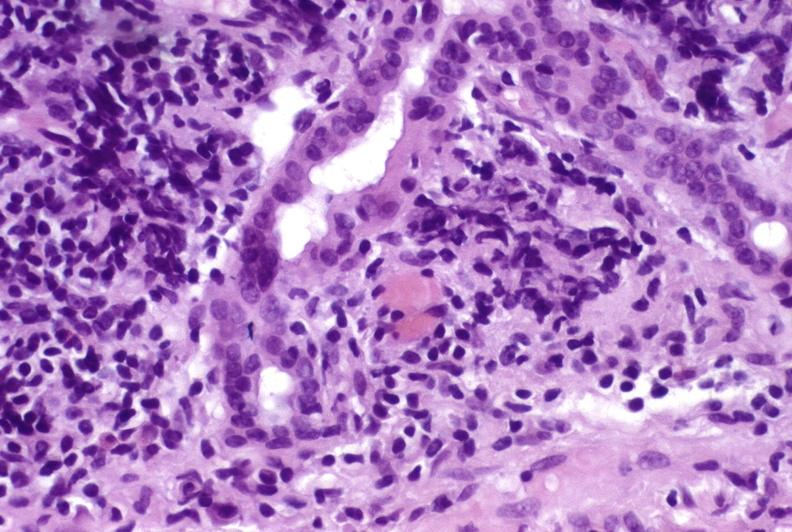what is present?
Answer the question using a single word or phrase. Hepatobiliary 